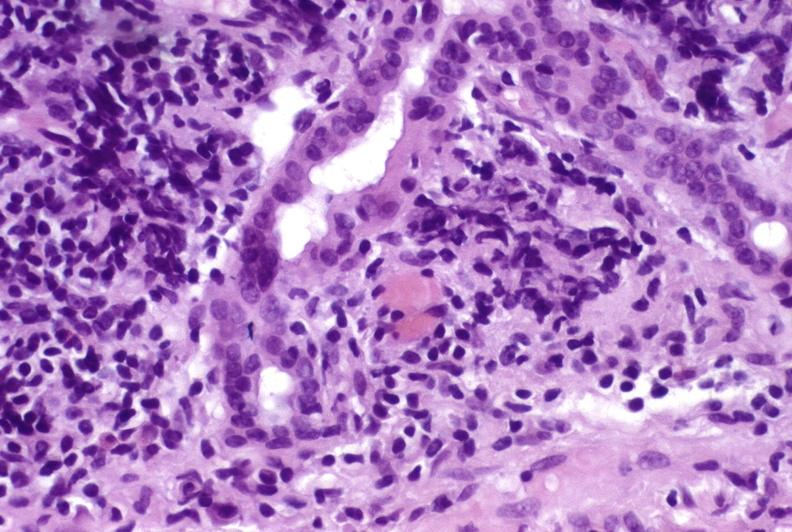what is present?
Answer the question using a single word or phrase. Hepatobiliary 